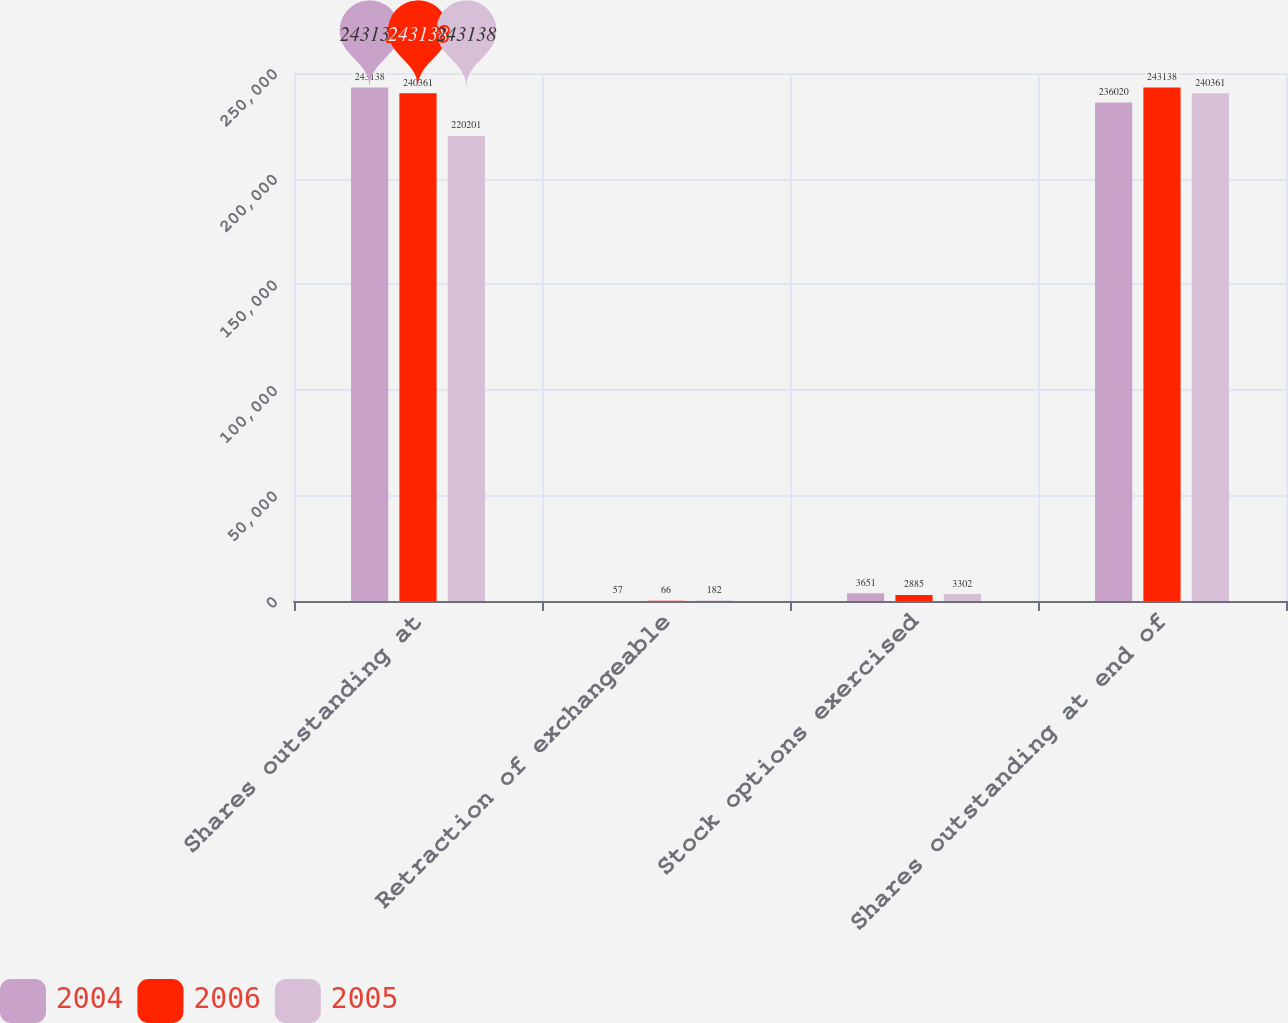Convert chart to OTSL. <chart><loc_0><loc_0><loc_500><loc_500><stacked_bar_chart><ecel><fcel>Shares outstanding at<fcel>Retraction of exchangeable<fcel>Stock options exercised<fcel>Shares outstanding at end of<nl><fcel>2004<fcel>243138<fcel>57<fcel>3651<fcel>236020<nl><fcel>2006<fcel>240361<fcel>66<fcel>2885<fcel>243138<nl><fcel>2005<fcel>220201<fcel>182<fcel>3302<fcel>240361<nl></chart> 